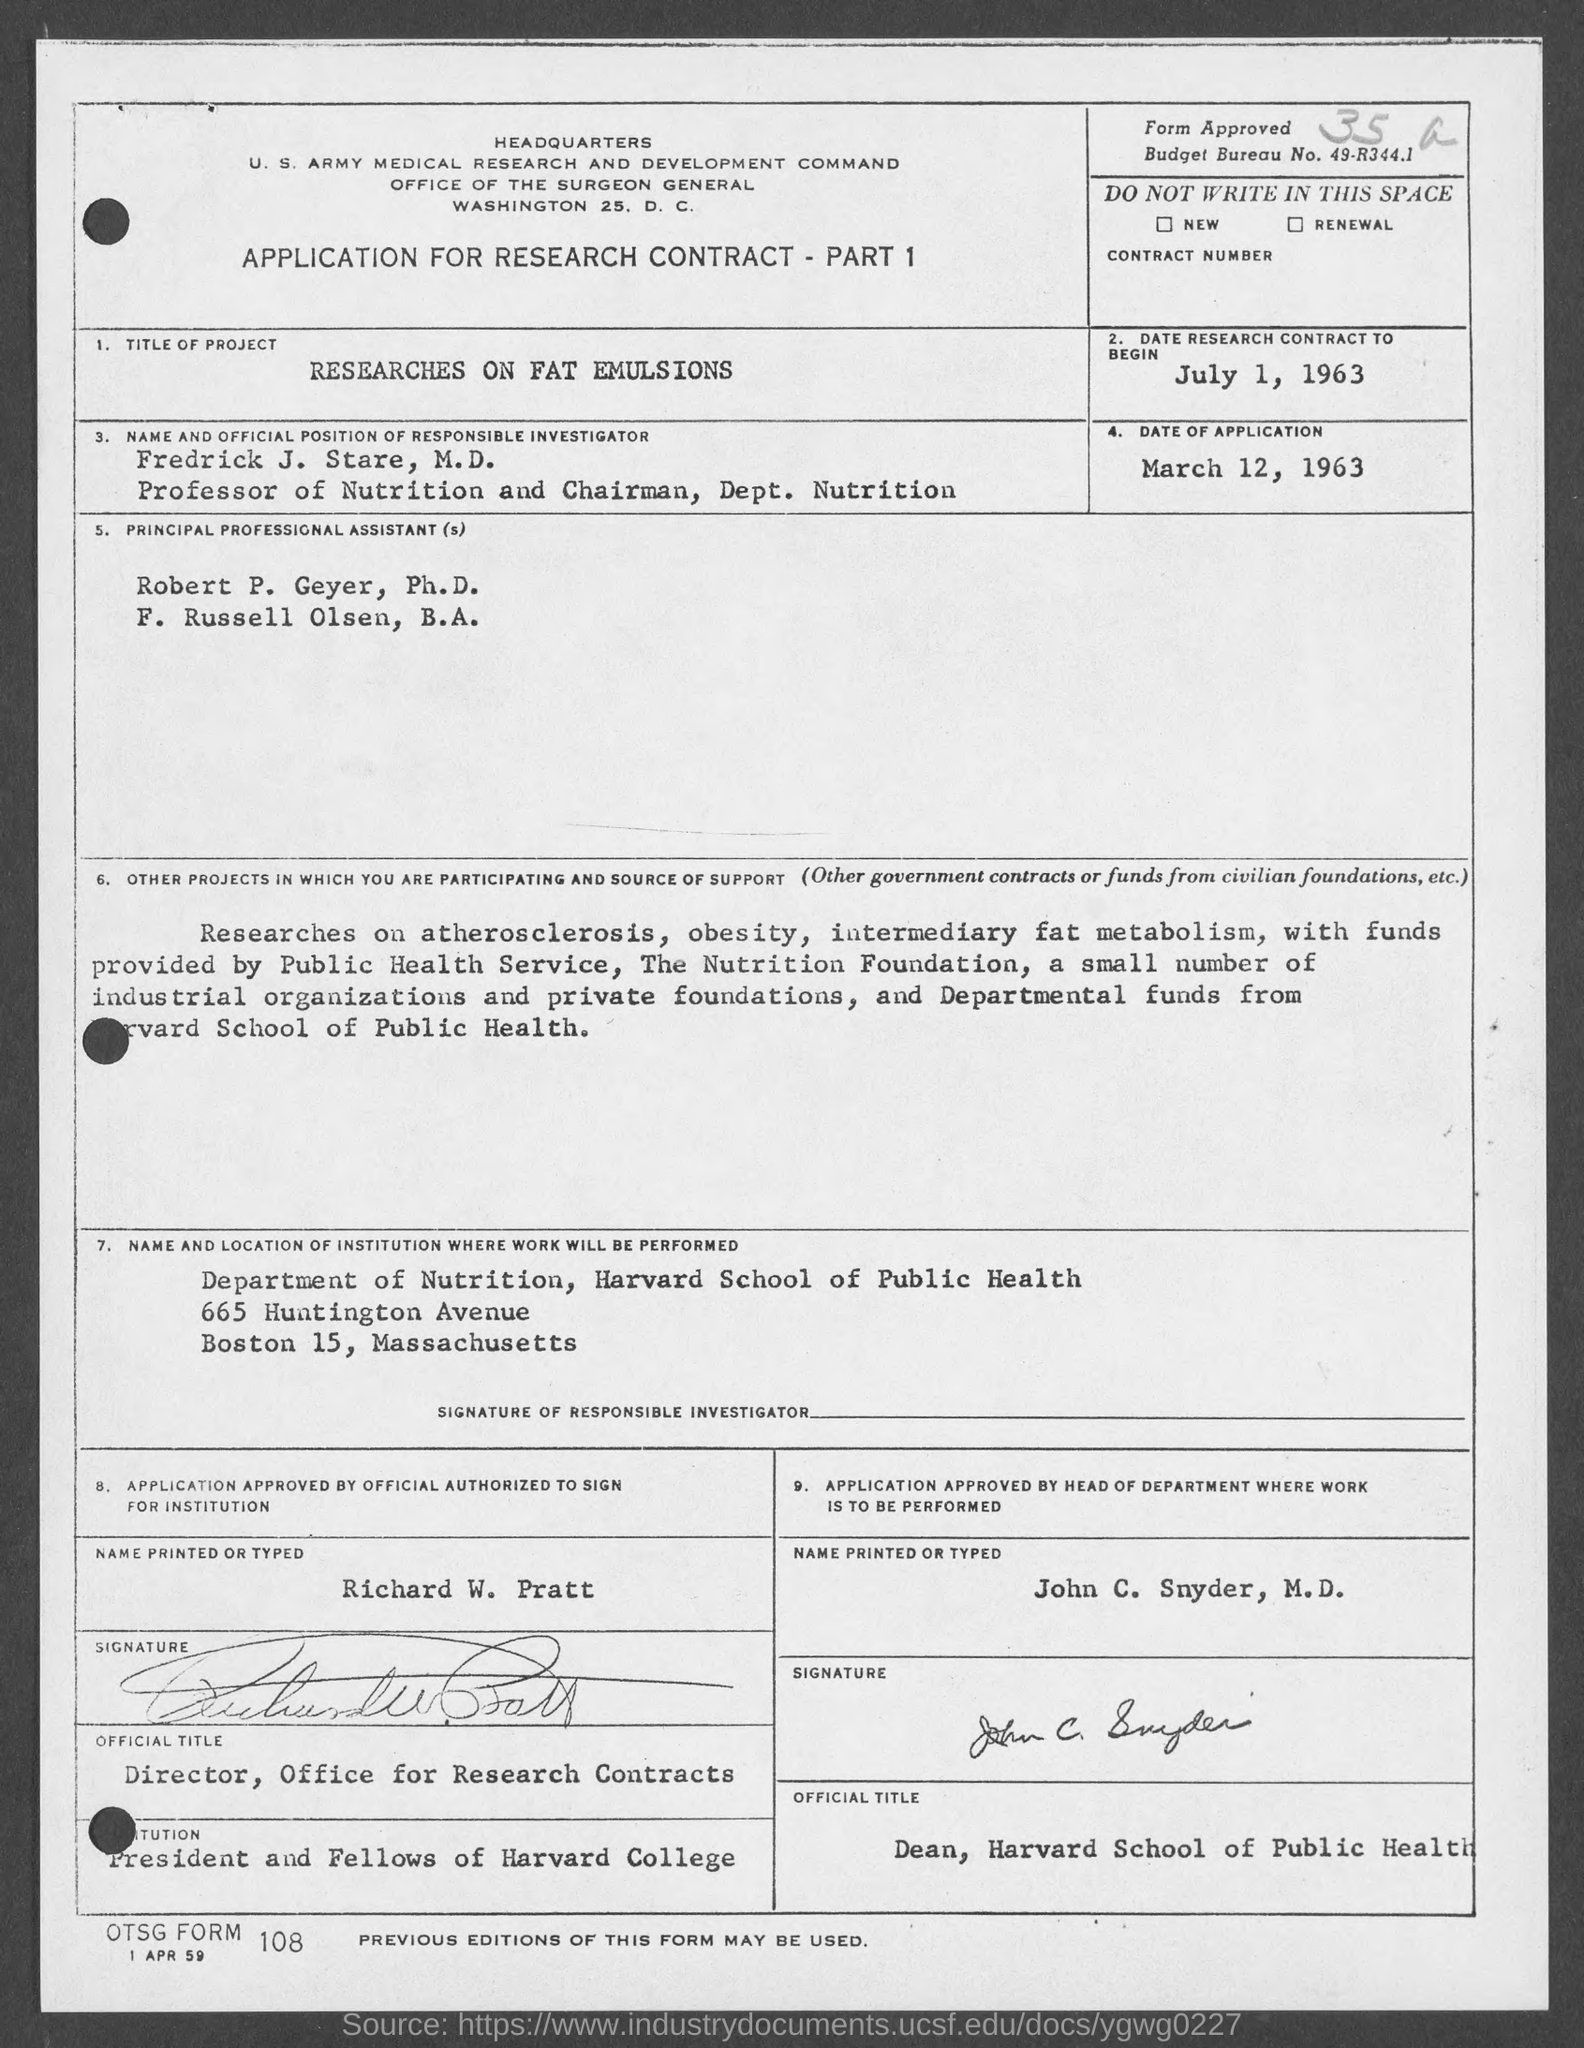What is the date research contract to begin at?
Your answer should be compact. July 1, 1963. What is the date of application?
Offer a very short reply. March 12, 1963. Who is the director of office for research contracts ?
Make the answer very short. Richard W. Pratt. What is the budget bureau no.?
Offer a terse response. 49-R344.1. What is otsg form no.?
Ensure brevity in your answer.  108. What is date at bottom of the page?
Provide a short and direct response. 1 Apr 59. 